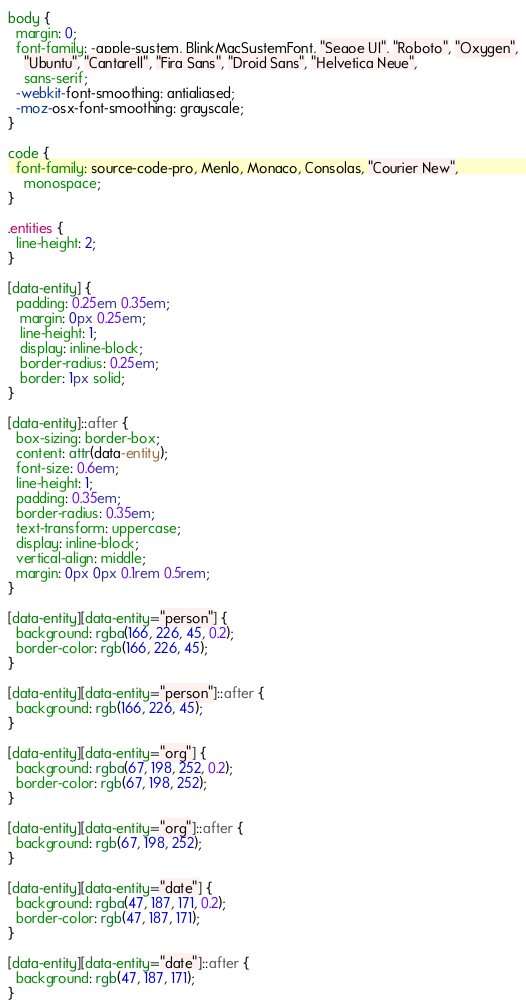Convert code to text. <code><loc_0><loc_0><loc_500><loc_500><_CSS_>body {
  margin: 0;
  font-family: -apple-system, BlinkMacSystemFont, "Segoe UI", "Roboto", "Oxygen",
    "Ubuntu", "Cantarell", "Fira Sans", "Droid Sans", "Helvetica Neue",
    sans-serif;
  -webkit-font-smoothing: antialiased;
  -moz-osx-font-smoothing: grayscale;
}

code {
  font-family: source-code-pro, Menlo, Monaco, Consolas, "Courier New",
    monospace;
}

.entities {
  line-height: 2;
}

[data-entity] {
  padding: 0.25em 0.35em;
   margin: 0px 0.25em;
   line-height: 1;
   display: inline-block;
   border-radius: 0.25em;
   border: 1px solid;
}

[data-entity]::after {
  box-sizing: border-box;
  content: attr(data-entity);
  font-size: 0.6em;
  line-height: 1;
  padding: 0.35em;
  border-radius: 0.35em;
  text-transform: uppercase;
  display: inline-block;
  vertical-align: middle;
  margin: 0px 0px 0.1rem 0.5rem;
}

[data-entity][data-entity="person"] {
  background: rgba(166, 226, 45, 0.2);
  border-color: rgb(166, 226, 45);
}

[data-entity][data-entity="person"]::after {
  background: rgb(166, 226, 45);
}

[data-entity][data-entity="org"] {
  background: rgba(67, 198, 252, 0.2);
  border-color: rgb(67, 198, 252);
}

[data-entity][data-entity="org"]::after {
  background: rgb(67, 198, 252);
}

[data-entity][data-entity="date"] {
  background: rgba(47, 187, 171, 0.2);
  border-color: rgb(47, 187, 171);
}

[data-entity][data-entity="date"]::after {
  background: rgb(47, 187, 171);
}</code> 